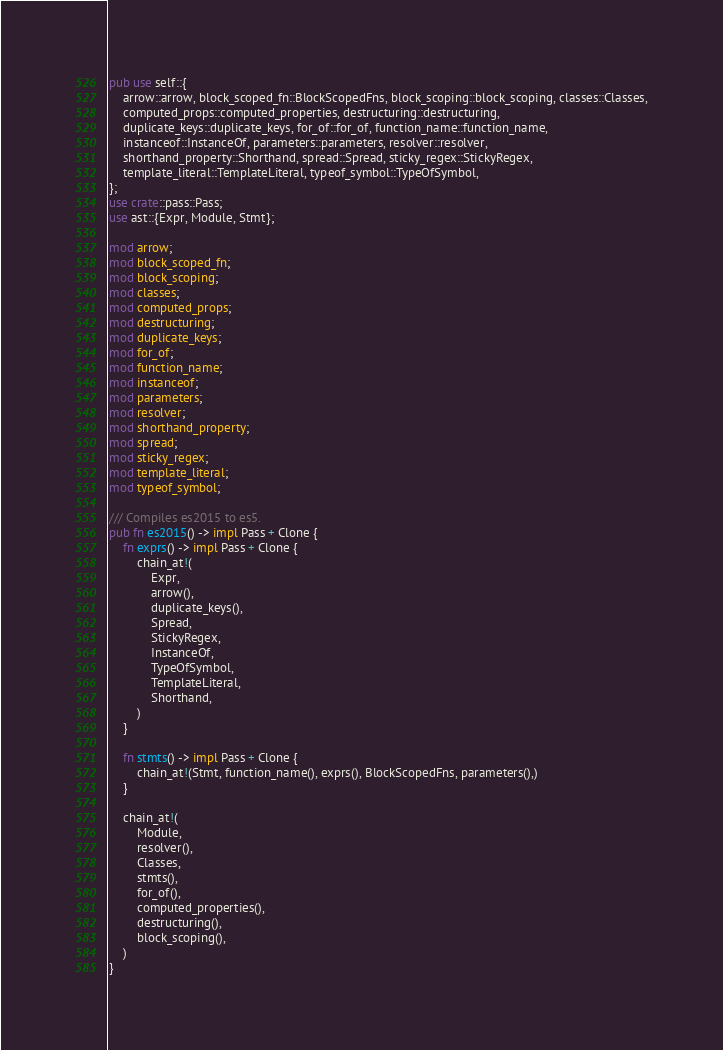<code> <loc_0><loc_0><loc_500><loc_500><_Rust_>pub use self::{
    arrow::arrow, block_scoped_fn::BlockScopedFns, block_scoping::block_scoping, classes::Classes,
    computed_props::computed_properties, destructuring::destructuring,
    duplicate_keys::duplicate_keys, for_of::for_of, function_name::function_name,
    instanceof::InstanceOf, parameters::parameters, resolver::resolver,
    shorthand_property::Shorthand, spread::Spread, sticky_regex::StickyRegex,
    template_literal::TemplateLiteral, typeof_symbol::TypeOfSymbol,
};
use crate::pass::Pass;
use ast::{Expr, Module, Stmt};

mod arrow;
mod block_scoped_fn;
mod block_scoping;
mod classes;
mod computed_props;
mod destructuring;
mod duplicate_keys;
mod for_of;
mod function_name;
mod instanceof;
mod parameters;
mod resolver;
mod shorthand_property;
mod spread;
mod sticky_regex;
mod template_literal;
mod typeof_symbol;

/// Compiles es2015 to es5.
pub fn es2015() -> impl Pass + Clone {
    fn exprs() -> impl Pass + Clone {
        chain_at!(
            Expr,
            arrow(),
            duplicate_keys(),
            Spread,
            StickyRegex,
            InstanceOf,
            TypeOfSymbol,
            TemplateLiteral,
            Shorthand,
        )
    }

    fn stmts() -> impl Pass + Clone {
        chain_at!(Stmt, function_name(), exprs(), BlockScopedFns, parameters(),)
    }

    chain_at!(
        Module,
        resolver(),
        Classes,
        stmts(),
        for_of(),
        computed_properties(),
        destructuring(),
        block_scoping(),
    )
}
</code> 